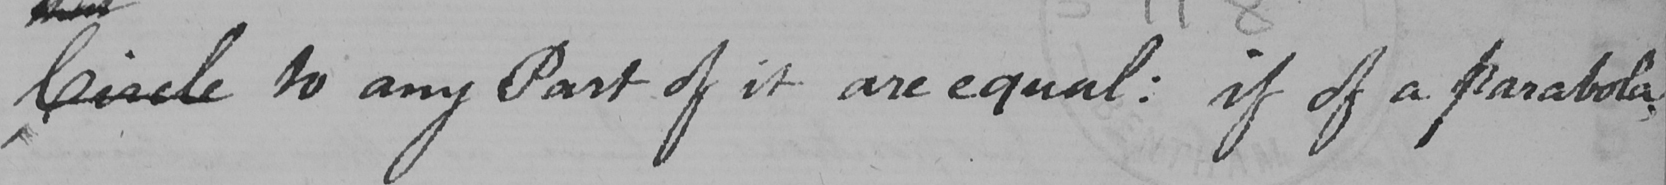What text is written in this handwritten line? Circle to any Part of it are equal :  if of a parabola , 